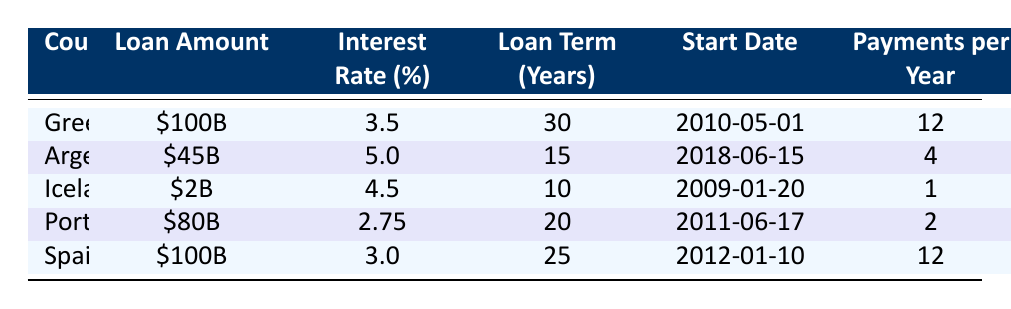What is the loan amount taken by Greece? The table shows Greece's loan amount listed directly under the "Loan Amount" column, which is \$100B.
Answer: \$100B Which country has the highest interest rate? By comparing the "Interest Rate (%)" column for each country listed in the table, Argentina has the highest interest rate at 5.0%.
Answer: Argentina How long is Portugal's loan term? The loan term for Portugal is directly provided in the "Loan Term (Years)" column, which indicates it is 20 years.
Answer: 20 years What is the total amount of loans taken by Greece and Spain? The loan amounts for Greece and Spain are \$100B and \$100B, respectively. Adding these amounts gives 100B + 100B = 200B.
Answer: \$200B Is the loan amount taken by Iceland less than that of Argentina? Iceland's loan amount is \$2B while Argentina's is \$45B. Since \$2B is less than \$45B, the statement is true.
Answer: Yes Which country has the longest repayment period? The "Loan Term (Years)" shows that Greece has the longest loan term of 30 years compared to other countries.
Answer: Greece What is the average interest rate for the loans taken by the countries listed? To find the average interest rate: (3.5 + 5.0 + 4.5 + 2.75 + 3.0) / 5 = 18.75 / 5 = 3.75%.
Answer: 3.75% Which country has the smallest loan amount and what is it? The table shows Iceland has the smallest loan amount of \$2B. This can be verified by comparing the amounts in the "Loan Amount" column.
Answer: \$2B Is it true that all the countries took loans with an interest rate below 6%? Upon reviewing the interest rates, all listed countries have interest rates (3.5%, 5.0%, 4.5%, 2.75%, 3.0%) below 6%, therefore the statement is true.
Answer: Yes 